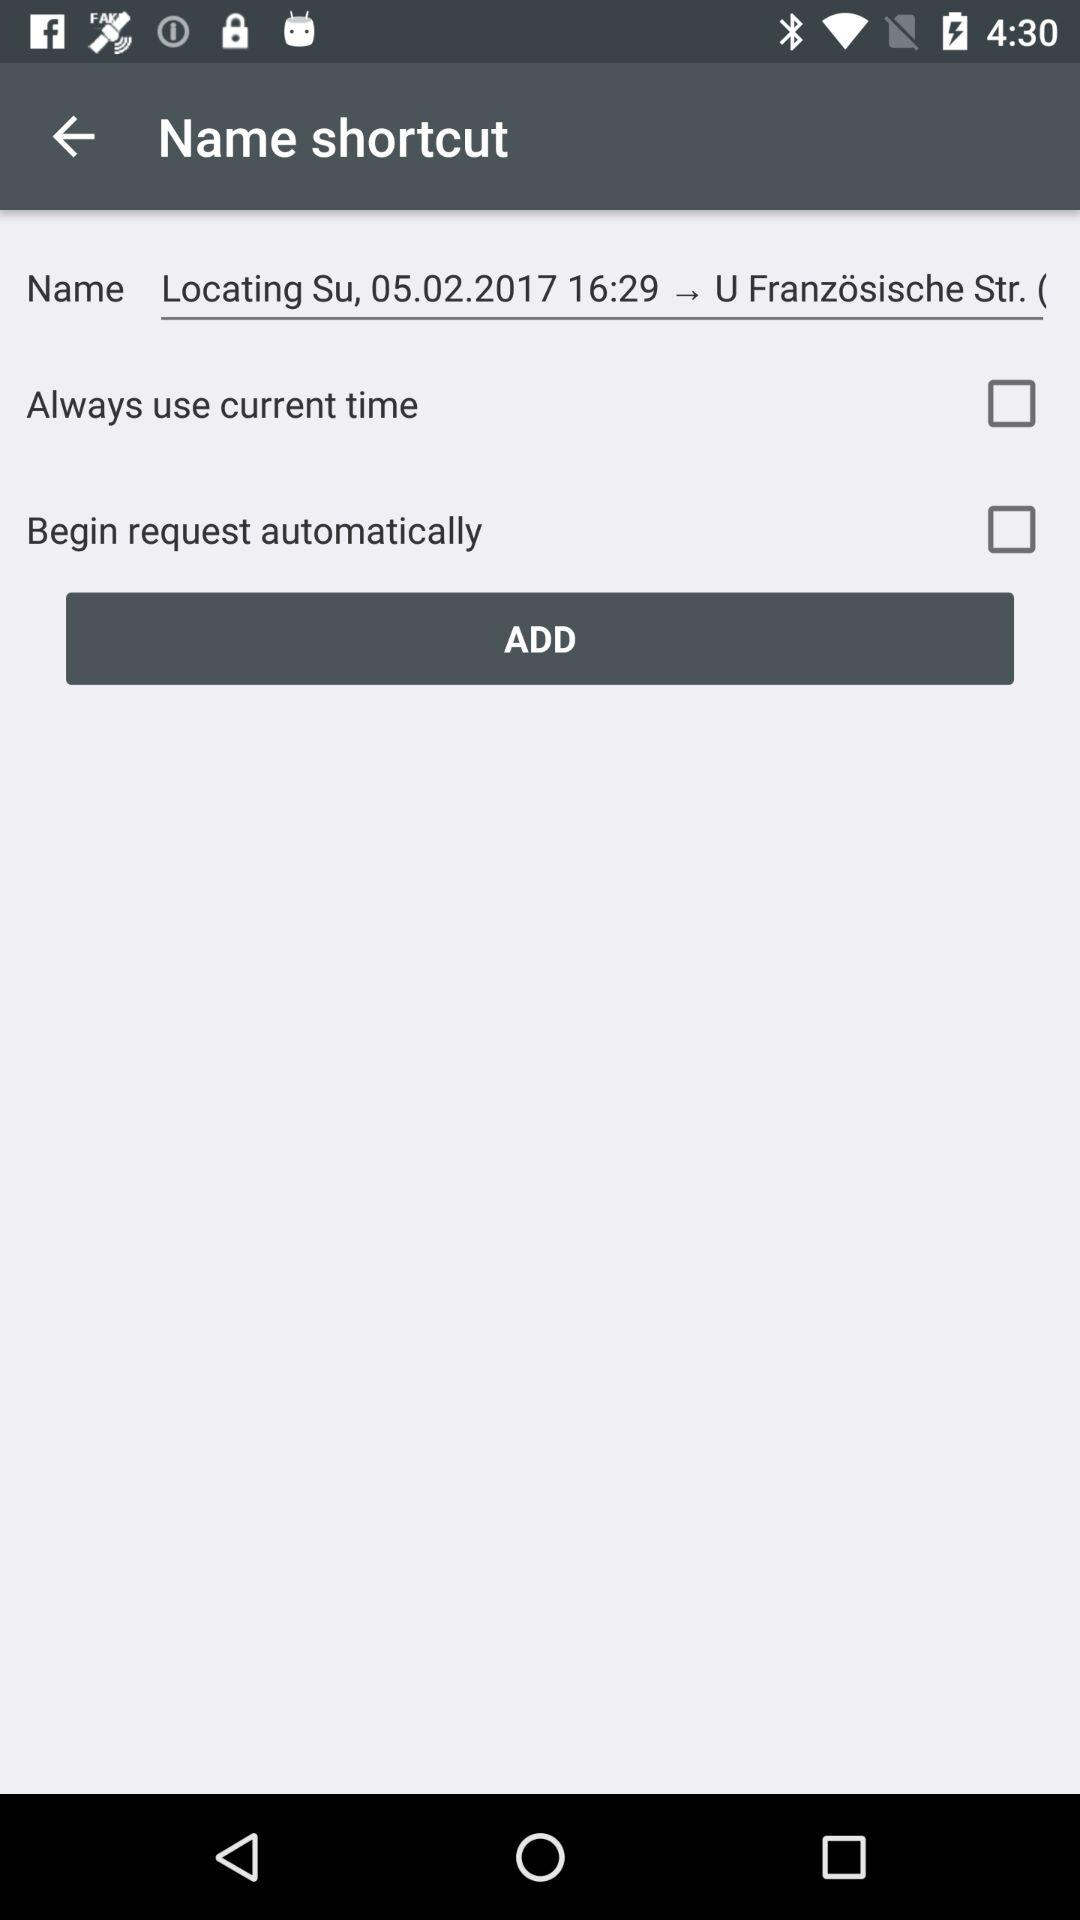What is the status of "Always use current time"? The status is "off". 